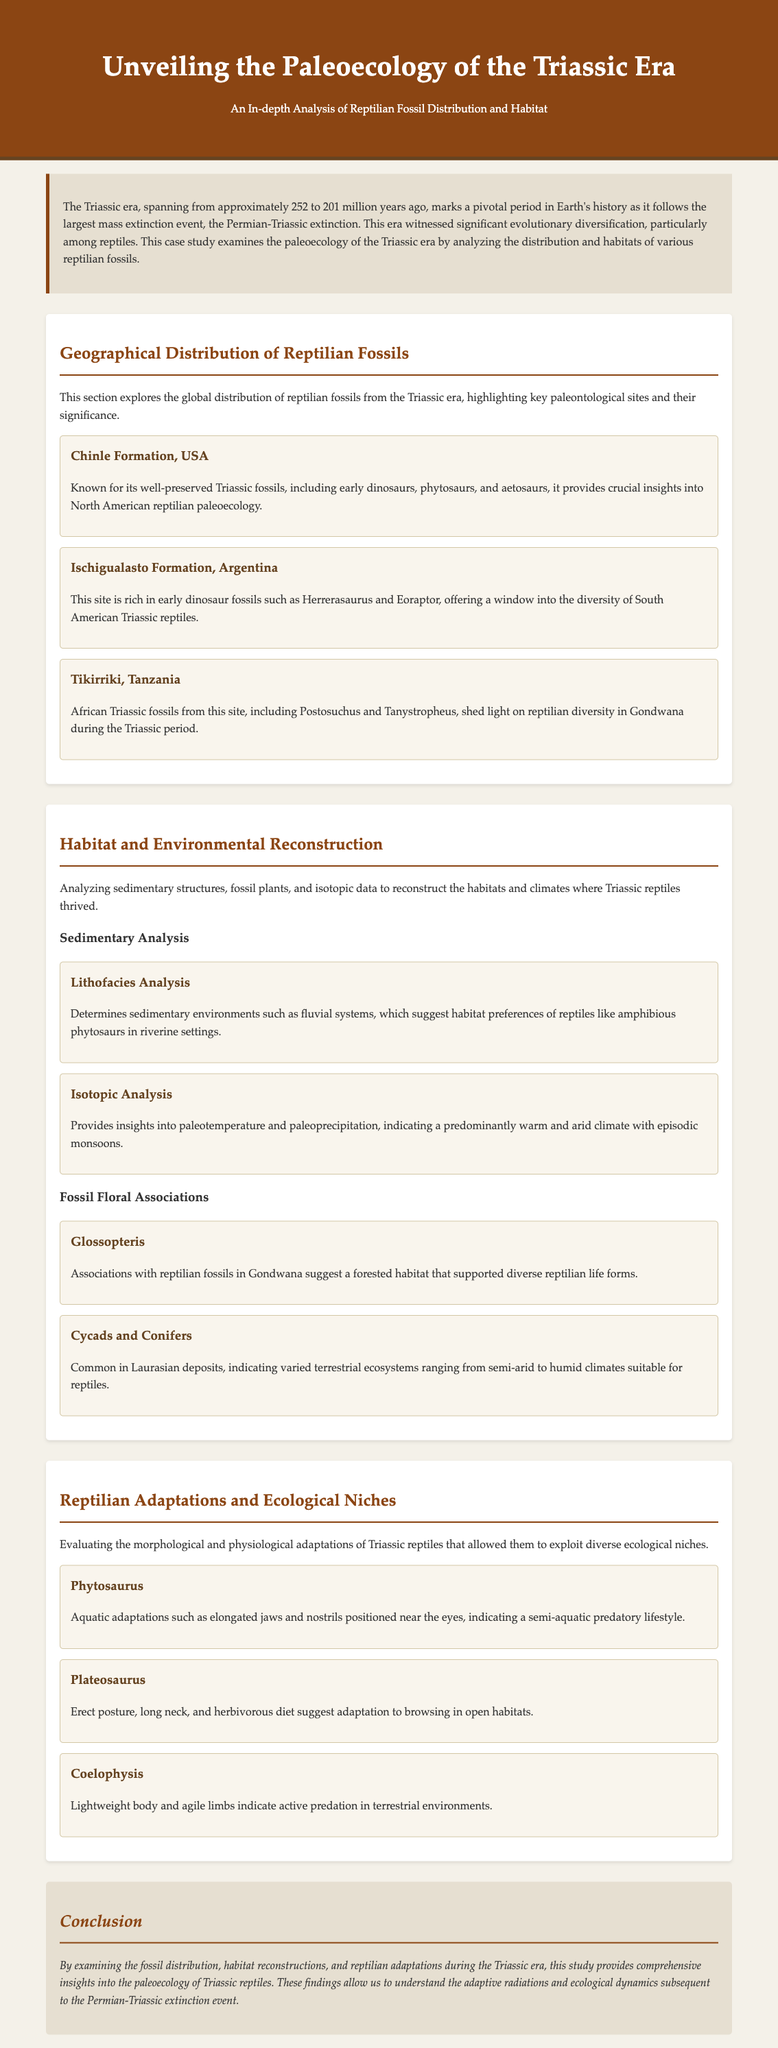What is the approximate time span of the Triassic era? The document states that the Triassic era spanned from approximately 252 to 201 million years ago.
Answer: 252 to 201 million years ago Which formation in the USA is known for its well-preserved Triassic fossils? The Chinle Formation is highlighted as a key paleontological site in the USA for Triassic fossils.
Answer: Chinle Formation What type of fossil is associated with Glossopteris in Gondwana? The document mentions that Glossopteris is associated with reptilian fossils, suggesting a forested habitat.
Answer: Reptilian fossils Which technique is used to determine sedimentary environments? Lithofacies Analysis determines sedimentary environments.
Answer: Lithofacies Analysis Which reptile is characterized by aquatic adaptations such as elongated jaws? The document describes Phytosaurus as having aquatic adaptations for a semi-aquatic predatory lifestyle.
Answer: Phytosaurus What are the floral associations common in Laurasian deposits? The document lists cycads and conifers as common floral associations in Laurasian deposits.
Answer: Cycads and Conifers What is the significant role of isotopic analysis in habitat reconstruction? Isotopic Analysis provides insights into paleotemperature and paleoprecipitation, indicating climate conditions.
Answer: Paleotemperature and paleoprecipitation Name one reptile that suggests adaptation to browsing in open habitats. Plateosaurus is identified as a reptile adapted for browsing in open habitats.
Answer: Plateosaurus 